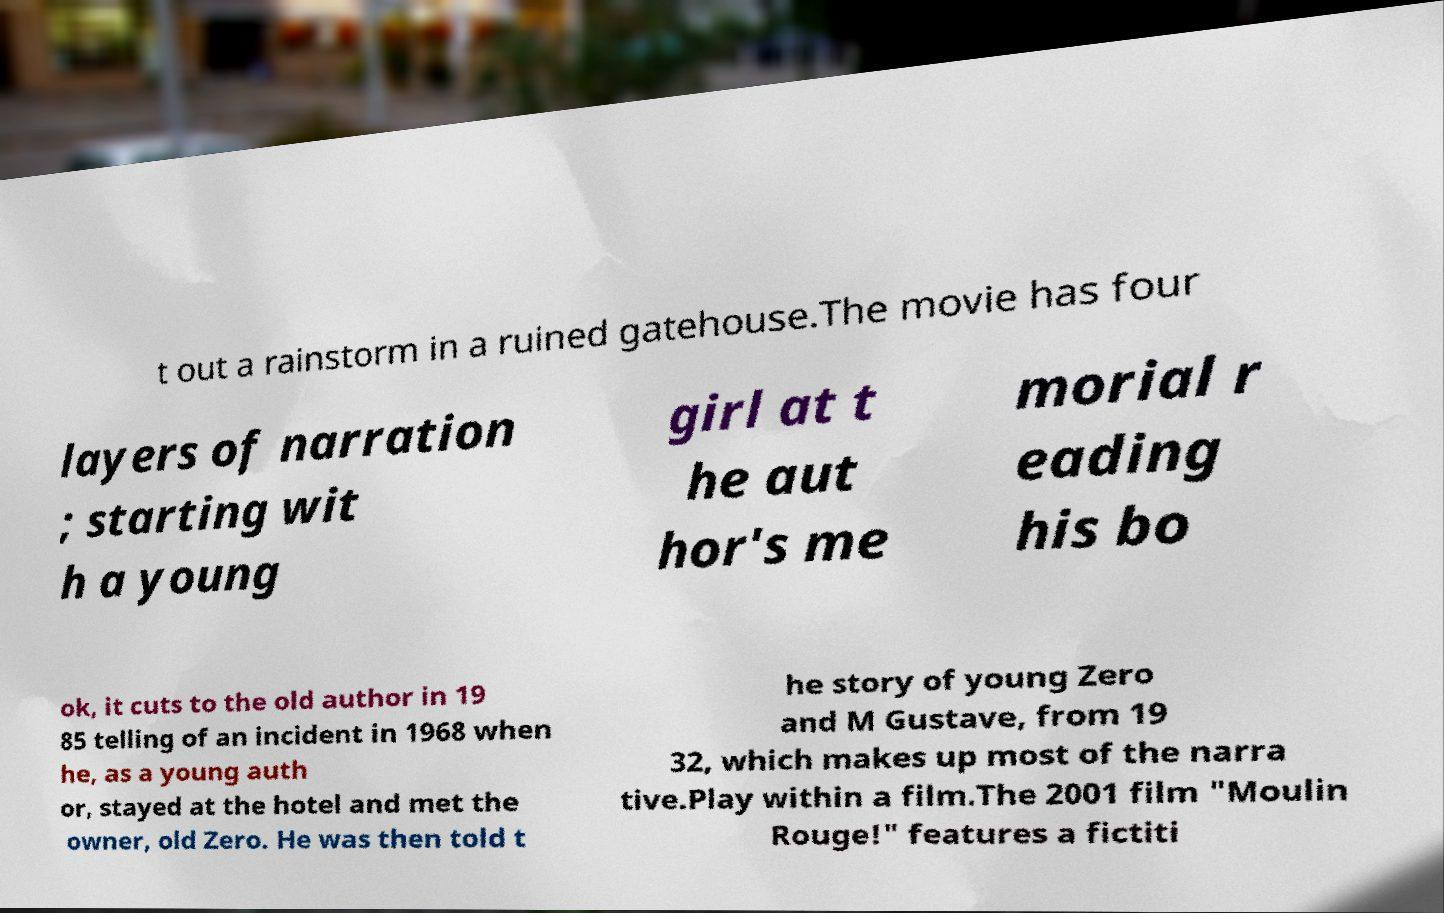Could you extract and type out the text from this image? t out a rainstorm in a ruined gatehouse.The movie has four layers of narration ; starting wit h a young girl at t he aut hor's me morial r eading his bo ok, it cuts to the old author in 19 85 telling of an incident in 1968 when he, as a young auth or, stayed at the hotel and met the owner, old Zero. He was then told t he story of young Zero and M Gustave, from 19 32, which makes up most of the narra tive.Play within a film.The 2001 film "Moulin Rouge!" features a fictiti 